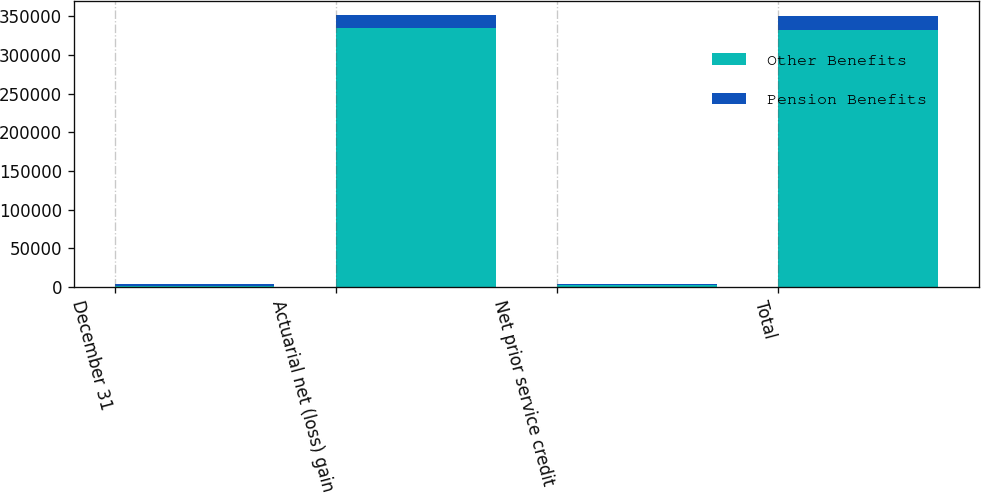<chart> <loc_0><loc_0><loc_500><loc_500><stacked_bar_chart><ecel><fcel>December 31<fcel>Actuarial net (loss) gain<fcel>Net prior service credit<fcel>Total<nl><fcel>Other Benefits<fcel>2008<fcel>335424<fcel>3015<fcel>332409<nl><fcel>Pension Benefits<fcel>2008<fcel>16588<fcel>1468<fcel>18056<nl></chart> 